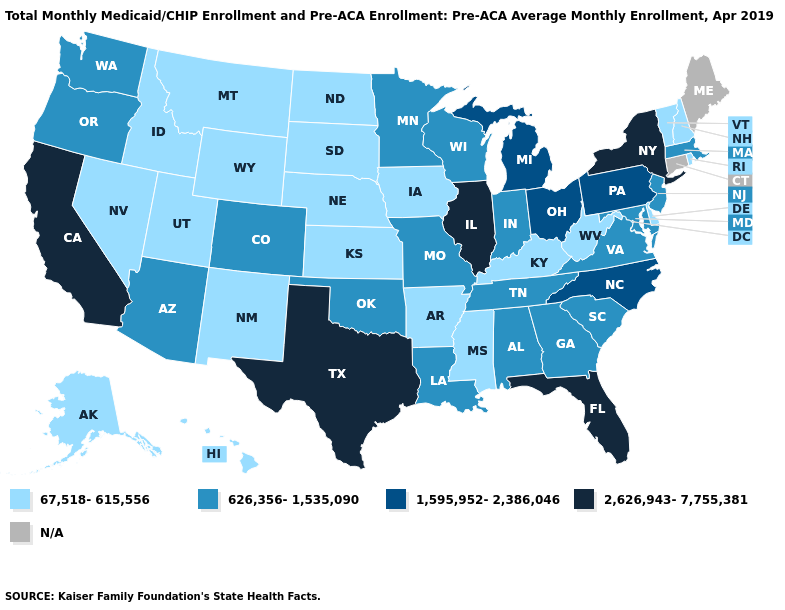Name the states that have a value in the range 626,356-1,535,090?
Concise answer only. Alabama, Arizona, Colorado, Georgia, Indiana, Louisiana, Maryland, Massachusetts, Minnesota, Missouri, New Jersey, Oklahoma, Oregon, South Carolina, Tennessee, Virginia, Washington, Wisconsin. Which states hav the highest value in the MidWest?
Short answer required. Illinois. Does New York have the highest value in the Northeast?
Quick response, please. Yes. What is the value of Maine?
Concise answer only. N/A. Which states have the lowest value in the USA?
Write a very short answer. Alaska, Arkansas, Delaware, Hawaii, Idaho, Iowa, Kansas, Kentucky, Mississippi, Montana, Nebraska, Nevada, New Hampshire, New Mexico, North Dakota, Rhode Island, South Dakota, Utah, Vermont, West Virginia, Wyoming. Among the states that border Georgia , which have the lowest value?
Give a very brief answer. Alabama, South Carolina, Tennessee. Which states have the lowest value in the MidWest?
Write a very short answer. Iowa, Kansas, Nebraska, North Dakota, South Dakota. Name the states that have a value in the range 1,595,952-2,386,046?
Keep it brief. Michigan, North Carolina, Ohio, Pennsylvania. What is the value of Virginia?
Give a very brief answer. 626,356-1,535,090. Which states hav the highest value in the Northeast?
Be succinct. New York. What is the value of Arkansas?
Give a very brief answer. 67,518-615,556. Among the states that border Montana , which have the lowest value?
Be succinct. Idaho, North Dakota, South Dakota, Wyoming. Name the states that have a value in the range 626,356-1,535,090?
Keep it brief. Alabama, Arizona, Colorado, Georgia, Indiana, Louisiana, Maryland, Massachusetts, Minnesota, Missouri, New Jersey, Oklahoma, Oregon, South Carolina, Tennessee, Virginia, Washington, Wisconsin. Does the first symbol in the legend represent the smallest category?
Give a very brief answer. Yes. 